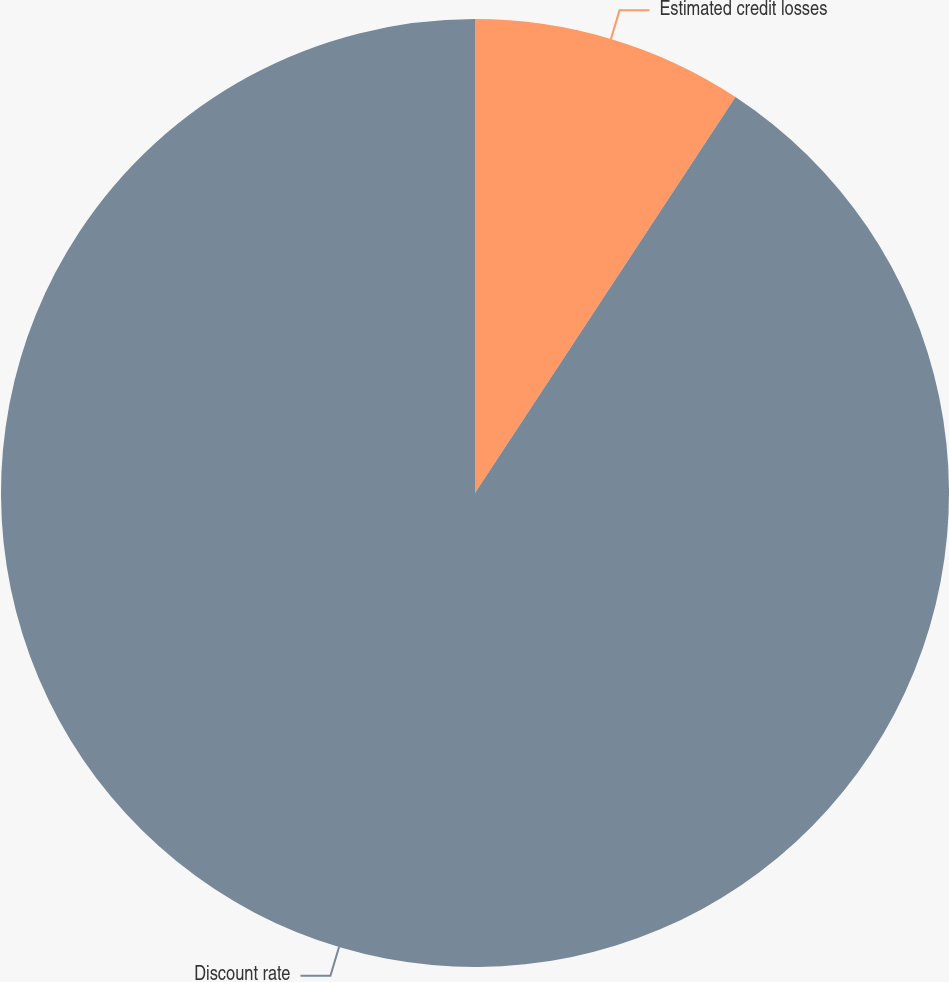Convert chart to OTSL. <chart><loc_0><loc_0><loc_500><loc_500><pie_chart><fcel>Estimated credit losses<fcel>Discount rate<nl><fcel>9.26%<fcel>90.74%<nl></chart> 